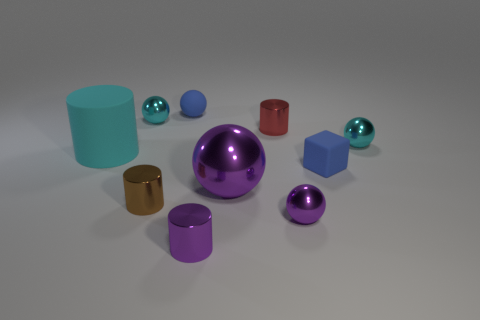What is the material of the cube that is the same color as the rubber ball?
Provide a succinct answer. Rubber. What number of other objects are there of the same shape as the small brown thing?
Your response must be concise. 3. Are there more small rubber things that are behind the tiny blue rubber block than big blue objects?
Provide a short and direct response. Yes. What is the size of the cyan rubber object that is the same shape as the brown metal thing?
Provide a succinct answer. Large. The brown shiny thing is what shape?
Offer a very short reply. Cylinder. There is a purple metallic thing that is the same size as the purple metallic cylinder; what shape is it?
Offer a terse response. Sphere. Is there anything else that has the same color as the matte cylinder?
Your answer should be compact. Yes. What size is the other purple sphere that is the same material as the tiny purple ball?
Offer a terse response. Large. Is the shape of the large cyan matte thing the same as the small purple metal object that is to the left of the small red shiny cylinder?
Your answer should be compact. Yes. What size is the rubber cylinder?
Keep it short and to the point. Large. 